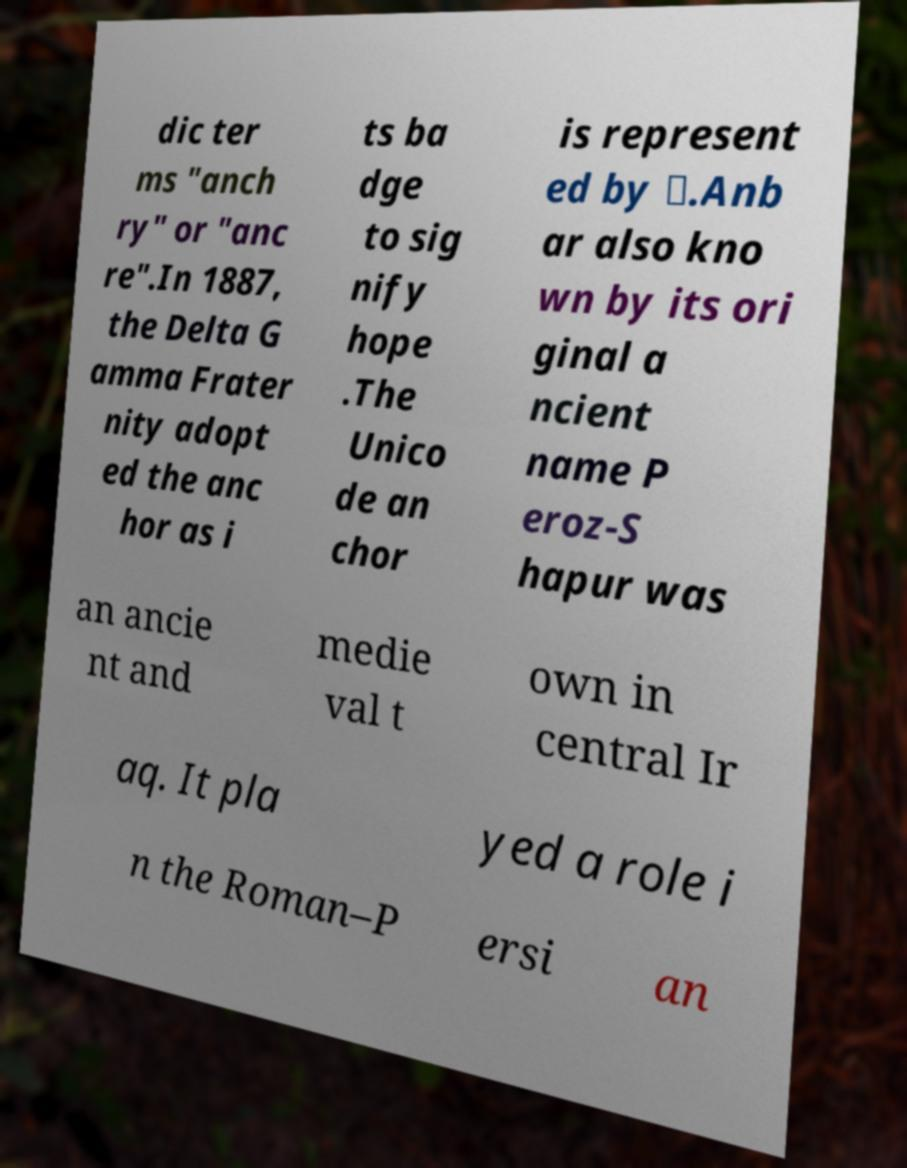Could you extract and type out the text from this image? dic ter ms "anch ry" or "anc re".In 1887, the Delta G amma Frater nity adopt ed the anc hor as i ts ba dge to sig nify hope .The Unico de an chor is represent ed by ⚓.Anb ar also kno wn by its ori ginal a ncient name P eroz-S hapur was an ancie nt and medie val t own in central Ir aq. It pla yed a role i n the Roman–P ersi an 